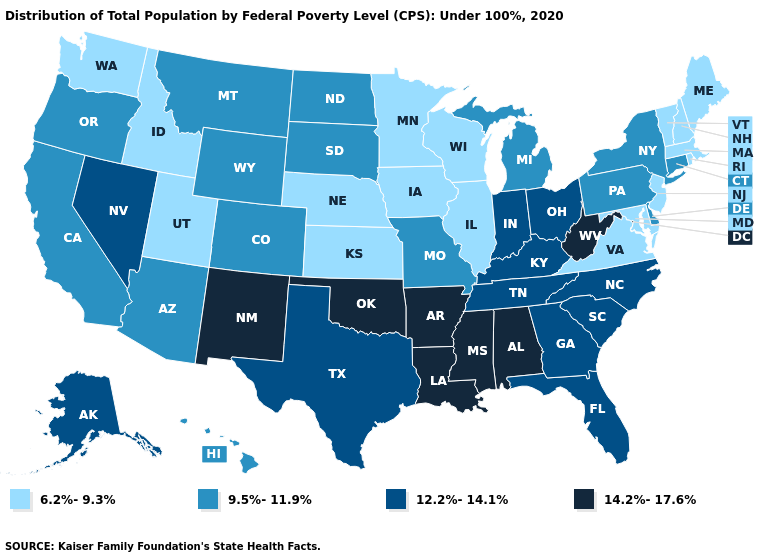Does Delaware have the lowest value in the South?
Give a very brief answer. No. How many symbols are there in the legend?
Keep it brief. 4. Name the states that have a value in the range 6.2%-9.3%?
Answer briefly. Idaho, Illinois, Iowa, Kansas, Maine, Maryland, Massachusetts, Minnesota, Nebraska, New Hampshire, New Jersey, Rhode Island, Utah, Vermont, Virginia, Washington, Wisconsin. What is the highest value in the South ?
Keep it brief. 14.2%-17.6%. Name the states that have a value in the range 9.5%-11.9%?
Give a very brief answer. Arizona, California, Colorado, Connecticut, Delaware, Hawaii, Michigan, Missouri, Montana, New York, North Dakota, Oregon, Pennsylvania, South Dakota, Wyoming. Which states have the lowest value in the MidWest?
Keep it brief. Illinois, Iowa, Kansas, Minnesota, Nebraska, Wisconsin. What is the highest value in the MidWest ?
Quick response, please. 12.2%-14.1%. Among the states that border Illinois , which have the highest value?
Concise answer only. Indiana, Kentucky. Name the states that have a value in the range 9.5%-11.9%?
Quick response, please. Arizona, California, Colorado, Connecticut, Delaware, Hawaii, Michigan, Missouri, Montana, New York, North Dakota, Oregon, Pennsylvania, South Dakota, Wyoming. Which states have the lowest value in the USA?
Quick response, please. Idaho, Illinois, Iowa, Kansas, Maine, Maryland, Massachusetts, Minnesota, Nebraska, New Hampshire, New Jersey, Rhode Island, Utah, Vermont, Virginia, Washington, Wisconsin. Does Tennessee have the highest value in the USA?
Answer briefly. No. What is the lowest value in the South?
Write a very short answer. 6.2%-9.3%. What is the value of New Hampshire?
Short answer required. 6.2%-9.3%. What is the highest value in the South ?
Short answer required. 14.2%-17.6%. What is the value of Minnesota?
Be succinct. 6.2%-9.3%. 